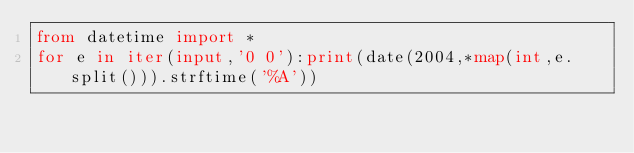Convert code to text. <code><loc_0><loc_0><loc_500><loc_500><_Python_>from datetime import *
for e in iter(input,'0 0'):print(date(2004,*map(int,e.split())).strftime('%A'))
</code> 